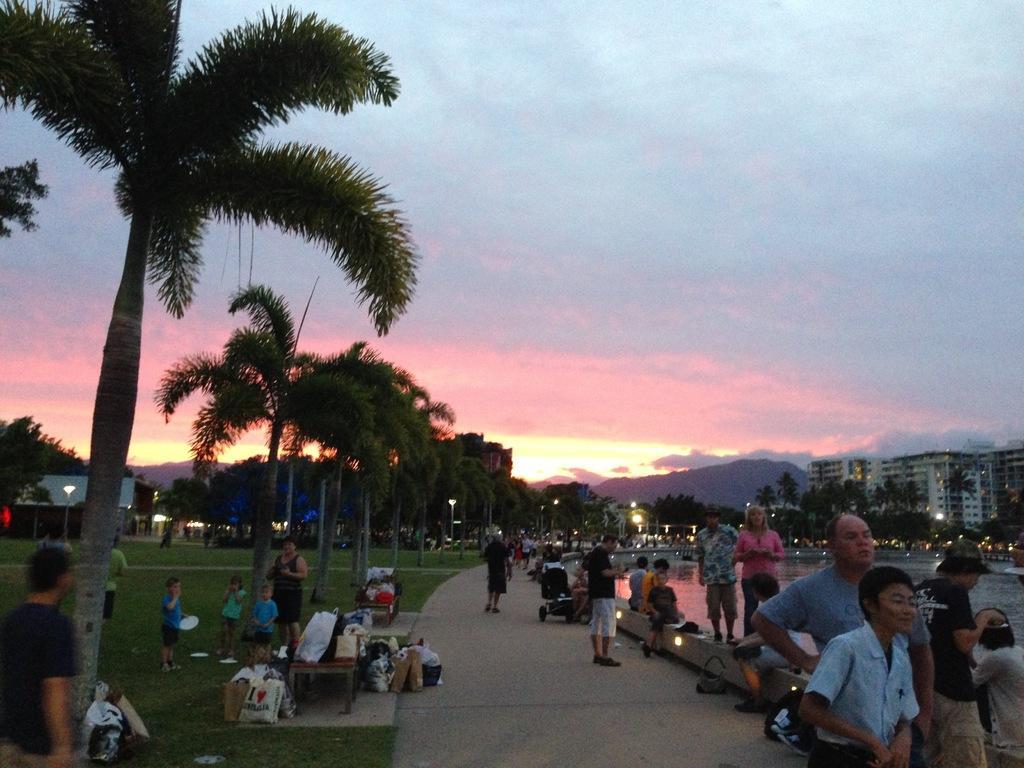Could you give a brief overview of what you see in this image? This picture shows trees and we see buildings and a cloudy sky and we see few people standing and few are seated and we see few bags on the table and floor and we see few pole lights and water. 